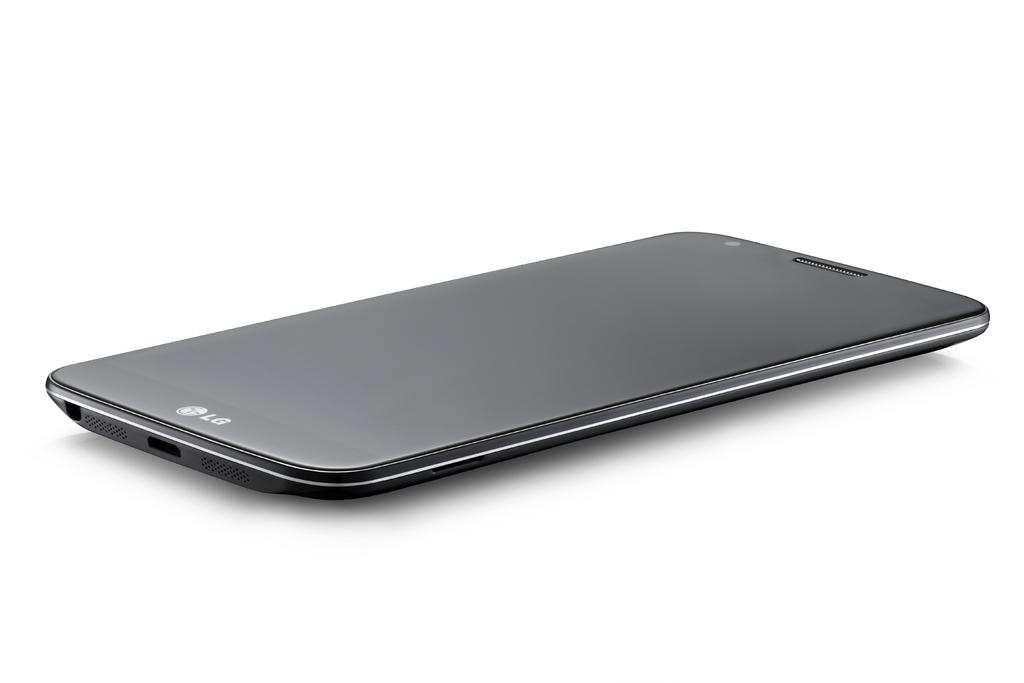Provide a one-sentence caption for the provided image. A sleek black Lg phone lies on it's back looking upward, it appears to be new. 